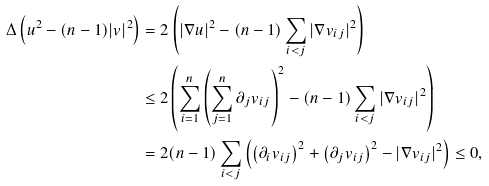Convert formula to latex. <formula><loc_0><loc_0><loc_500><loc_500>\Delta \left ( u ^ { 2 } - ( n - 1 ) | v | ^ { 2 } \right ) & = 2 \left ( | \nabla u | ^ { 2 } - ( n - 1 ) \sum _ { i < j } | \nabla v _ { i j } | ^ { 2 } \right ) \\ & \leq 2 \left ( \sum _ { i = 1 } ^ { n } \left ( \sum _ { j = 1 } ^ { n } \partial _ { j } v _ { i j } \right ) ^ { 2 } - ( n - 1 ) \sum _ { i < j } | \nabla v _ { i j } | ^ { 2 } \right ) \\ & = 2 ( n - 1 ) \sum _ { i < j } \left ( \left ( \partial _ { i } v _ { i j } \right ) ^ { 2 } + \left ( \partial _ { j } v _ { i j } \right ) ^ { 2 } - | \nabla v _ { i j } | ^ { 2 } \right ) \leq 0 ,</formula> 